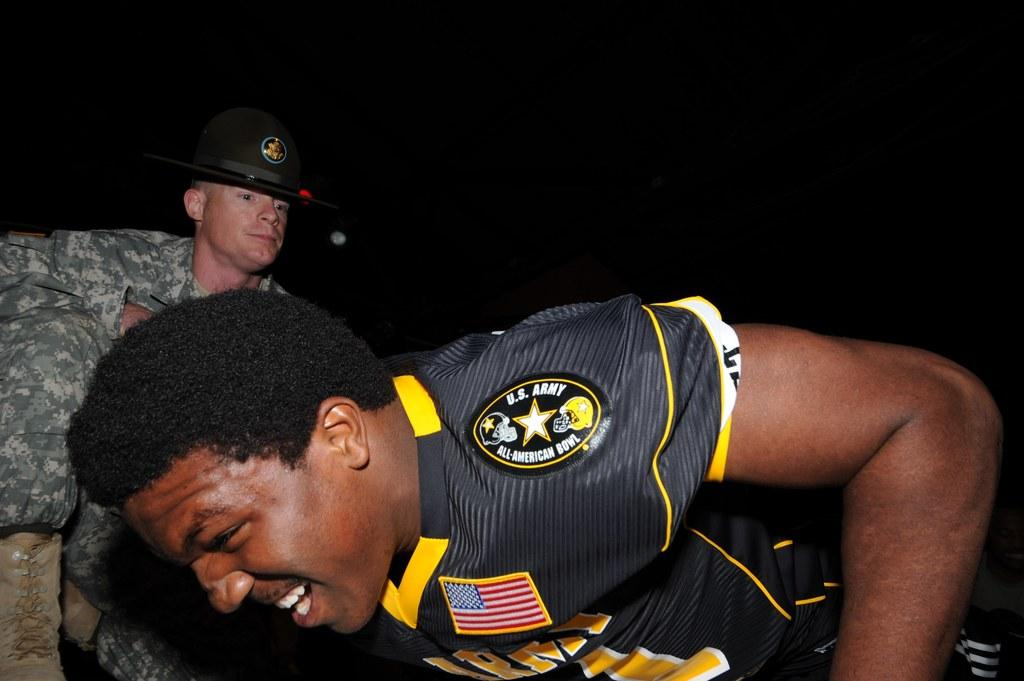<image>
Write a terse but informative summary of the picture. A football player celebrates at the U.S. Army All-American Bowl. 